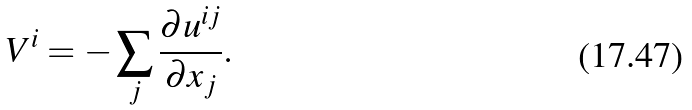Convert formula to latex. <formula><loc_0><loc_0><loc_500><loc_500>V ^ { i } = - \sum _ { j } \frac { \partial u ^ { i j } } { \partial x _ { j } } .</formula> 